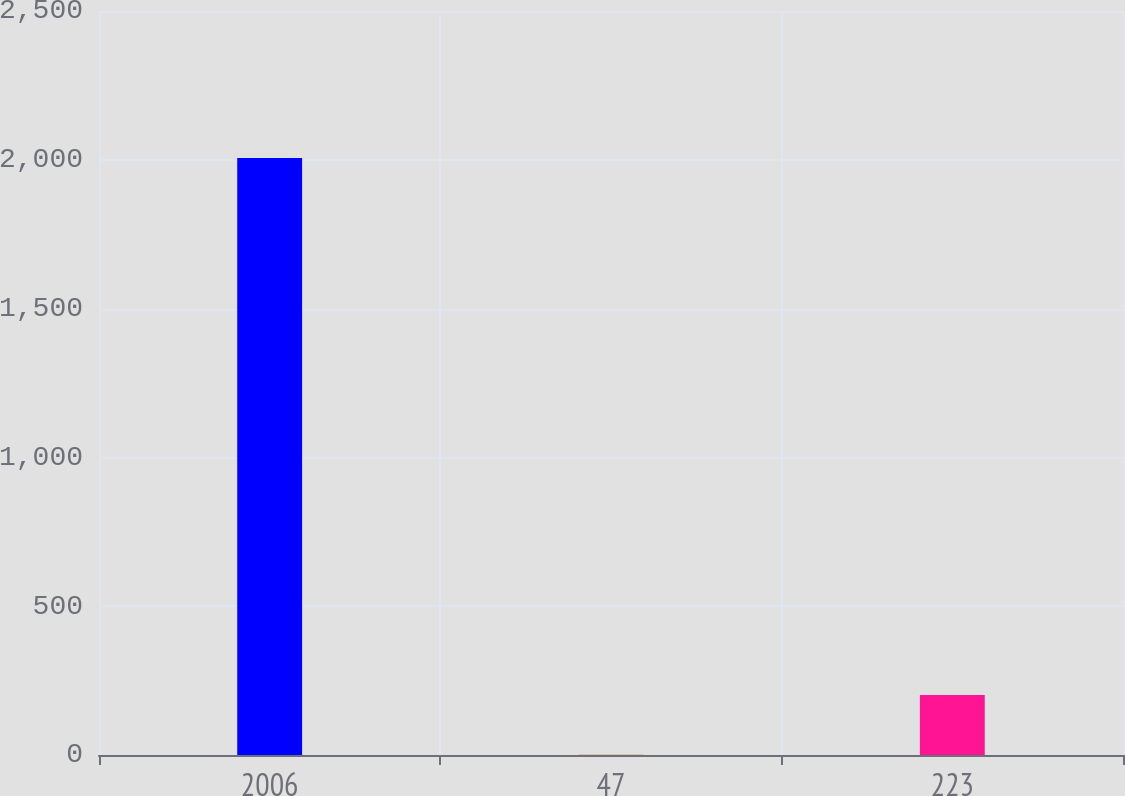Convert chart to OTSL. <chart><loc_0><loc_0><loc_500><loc_500><bar_chart><fcel>2006<fcel>47<fcel>223<nl><fcel>2006<fcel>1.3<fcel>201.77<nl></chart> 